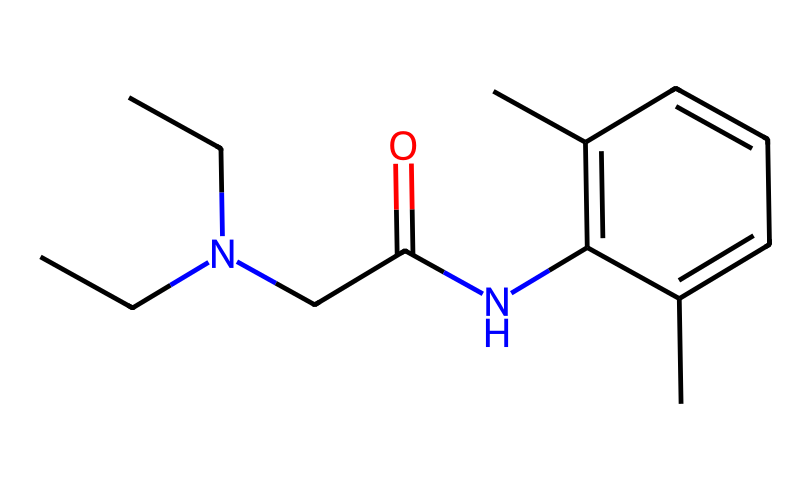What is the molecular formula of lidocaine? To determine the molecular formula, we count the number of each type of atom present in the provided SMILES representation. Breaking down the SMILES shows that there are 19 carbons (C), 25 hydrogens (H), 2 nitrogens (N), and 1 oxygen (O). Putting this together gives the molecular formula as C14H22N2O.
Answer: C14H22N2O How many nitrogen atoms are in lidocaine? By inspecting the SMILES representation, we identify the presence of two nitrogen atoms represented by "N". Thus, we count them directly from the structure.
Answer: 2 What functional groups are present in lidocaine? The SMILES indicates the presence of an amide group (due to the "C(=O)N" part) and the aliphatic amine group (as indicated by the "N(CC)(CC)" portion). Therefore, the main functional groups identified are the amide and the aliphatic amine.
Answer: amide and aliphatic amine What type of bonding exists between the carbon atoms in lidocaine? Analyzing the SMILES shows that the carbon atoms are primarily connected by single bonds, except for the double bond between carbon and oxygen in the carbonyl of the amide group. Hence, most are single covalent bonds.
Answer: single bonds Is lidocaine a polar or nonpolar molecule? To assess polarity, we consider the functional groups and the overall molecular structure. The presence of the amide and nitrogen typically suggests some polar characteristics; however, the overall structure is largely hydrocarbon. So while it has polar attributes, the dominating hydrophobic regions lean towards being nonpolar overall.
Answer: nonpolar 